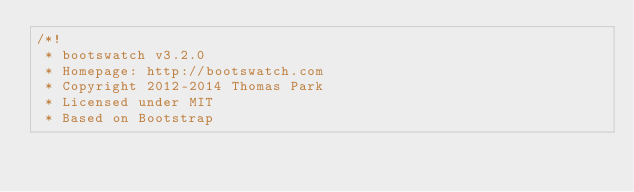Convert code to text. <code><loc_0><loc_0><loc_500><loc_500><_CSS_>/*!
 * bootswatch v3.2.0
 * Homepage: http://bootswatch.com
 * Copyright 2012-2014 Thomas Park
 * Licensed under MIT
 * Based on Bootstrap</code> 